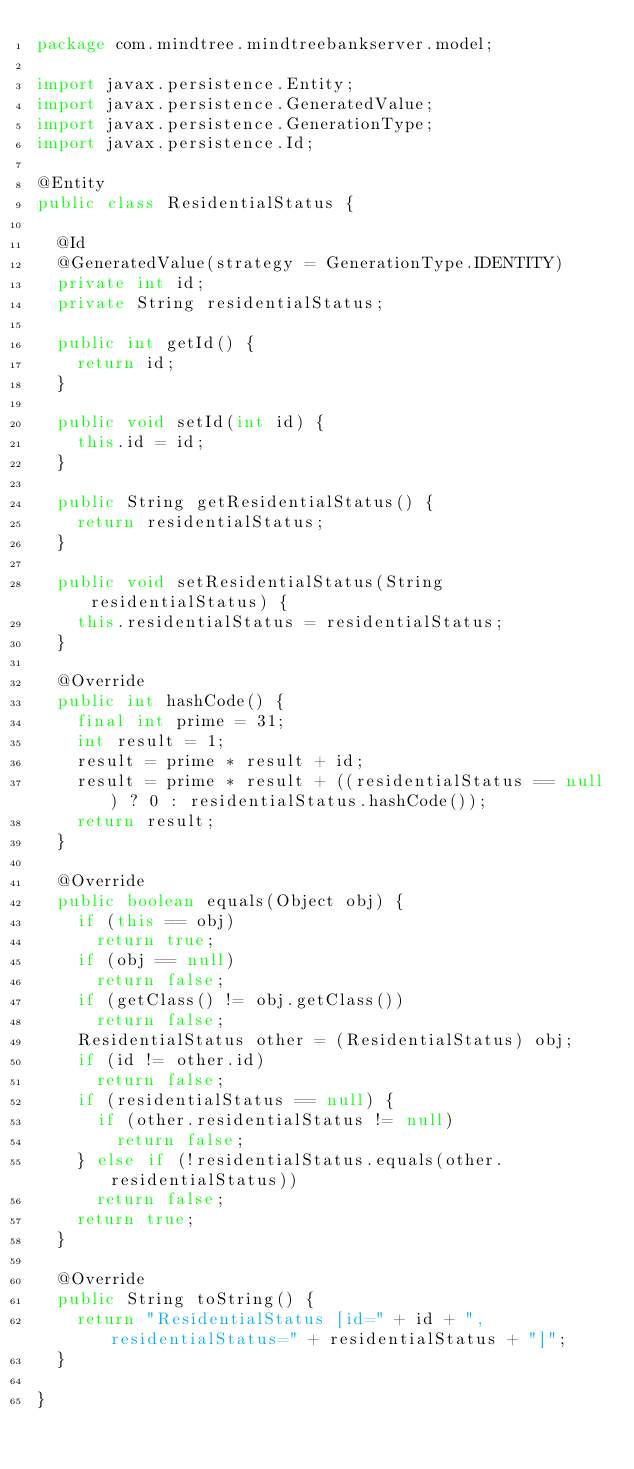Convert code to text. <code><loc_0><loc_0><loc_500><loc_500><_Java_>package com.mindtree.mindtreebankserver.model;

import javax.persistence.Entity;
import javax.persistence.GeneratedValue;
import javax.persistence.GenerationType;
import javax.persistence.Id;

@Entity
public class ResidentialStatus {

	@Id
	@GeneratedValue(strategy = GenerationType.IDENTITY)
	private int id;
	private String residentialStatus;

	public int getId() {
		return id;
	}

	public void setId(int id) {
		this.id = id;
	}

	public String getResidentialStatus() {
		return residentialStatus;
	}

	public void setResidentialStatus(String residentialStatus) {
		this.residentialStatus = residentialStatus;
	}

	@Override
	public int hashCode() {
		final int prime = 31;
		int result = 1;
		result = prime * result + id;
		result = prime * result + ((residentialStatus == null) ? 0 : residentialStatus.hashCode());
		return result;
	}

	@Override
	public boolean equals(Object obj) {
		if (this == obj)
			return true;
		if (obj == null)
			return false;
		if (getClass() != obj.getClass())
			return false;
		ResidentialStatus other = (ResidentialStatus) obj;
		if (id != other.id)
			return false;
		if (residentialStatus == null) {
			if (other.residentialStatus != null)
				return false;
		} else if (!residentialStatus.equals(other.residentialStatus))
			return false;
		return true;
	}

	@Override
	public String toString() {
		return "ResidentialStatus [id=" + id + ", residentialStatus=" + residentialStatus + "]";
	}

}
</code> 